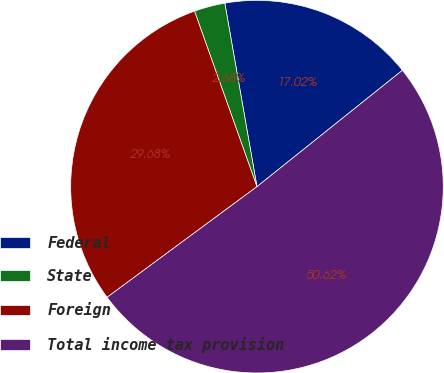<chart> <loc_0><loc_0><loc_500><loc_500><pie_chart><fcel>Federal<fcel>State<fcel>Foreign<fcel>Total income tax provision<nl><fcel>17.02%<fcel>2.68%<fcel>29.68%<fcel>50.62%<nl></chart> 